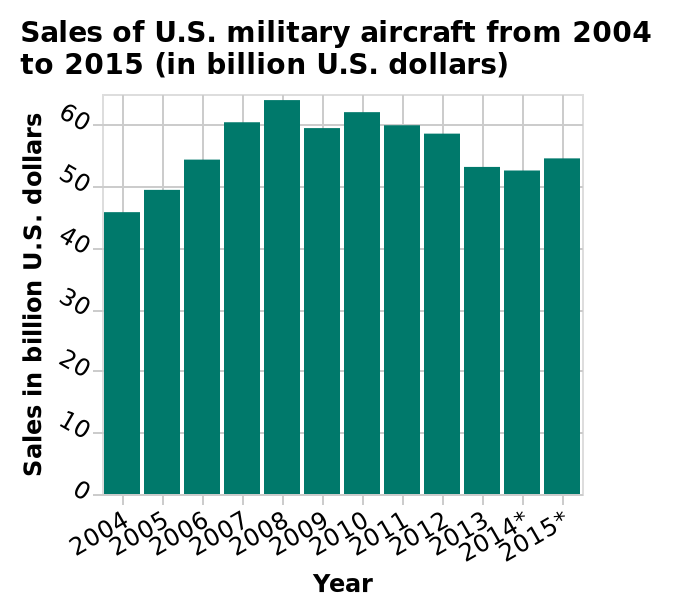<image>
In which year did the sales start dropping off?  The sales started dropping off by 2015. What were the peak years for sales?  The peak years for sales were from 2007 to 2012. Offer a thorough analysis of the image. 2007 to 2012 seem to be the peak years for sales as they are all similarly high, but there is a drop off by 2015.  After 2005 none of the sales in following years are as low. 